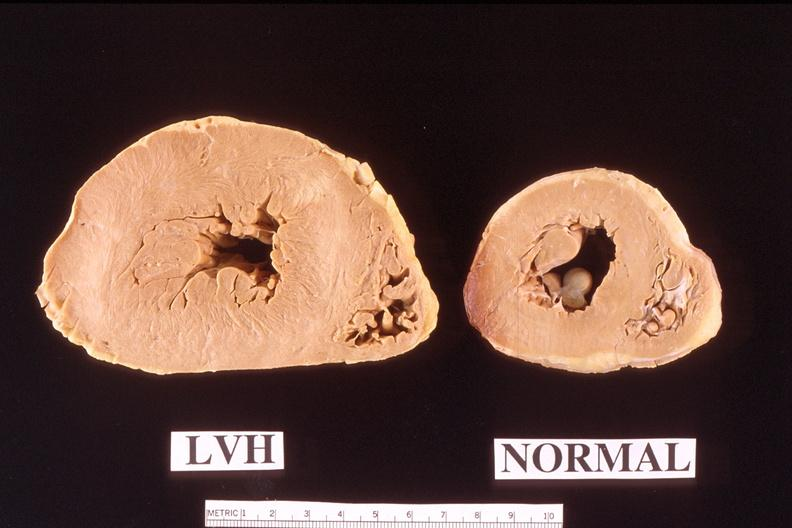what is present?
Answer the question using a single word or phrase. Cardiovascular 